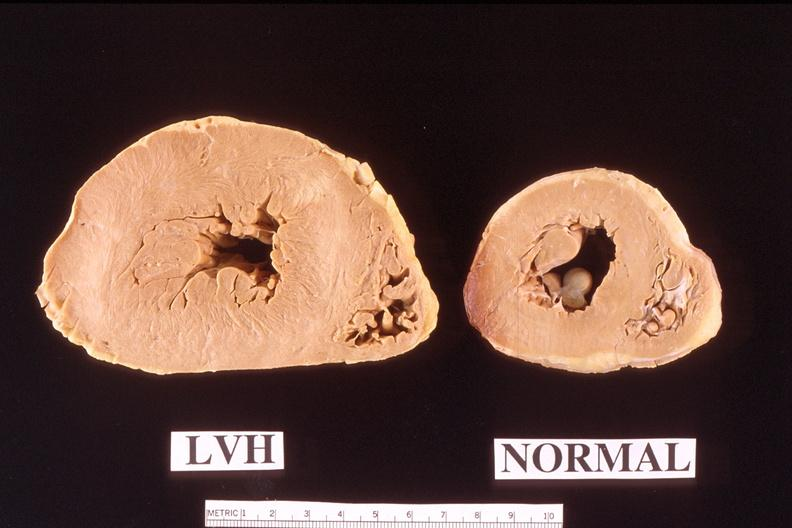what is present?
Answer the question using a single word or phrase. Cardiovascular 